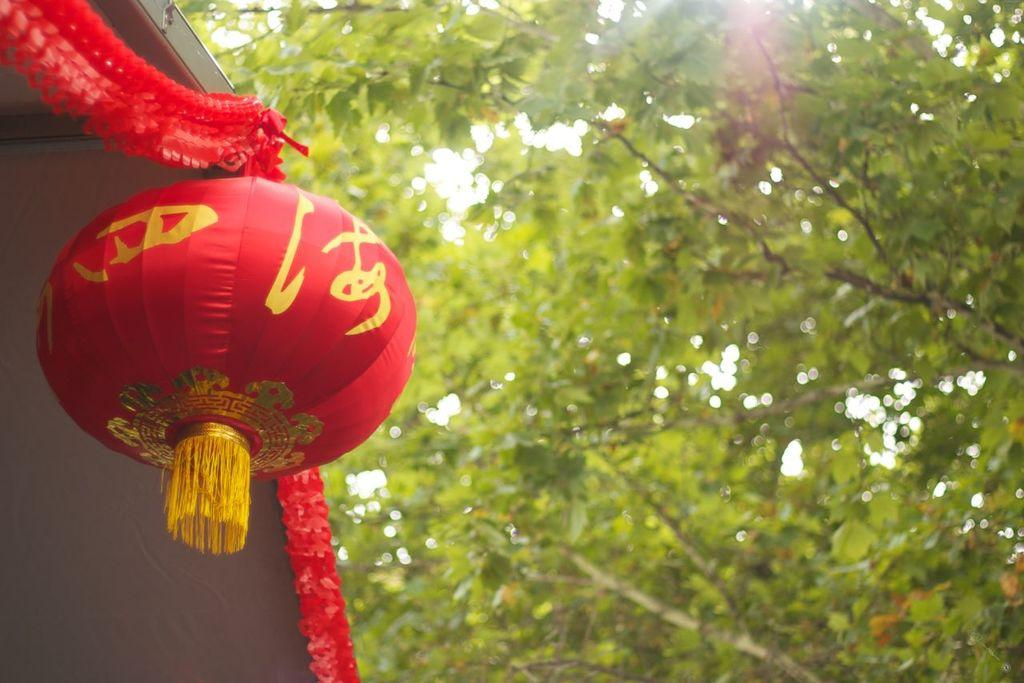What type of decor is present in the image? There is a decor in the image, but the specific type cannot be determined from the provided facts. What other element can be seen in the image besides the decor? There is a tree in the image. What type of instrument is being played by the tree in the image? There is no instrument present in the image, and the tree is not playing any instrument. What brand of toothpaste is visible on the decor in the image? There is no toothpaste visible on the decor in the image. 